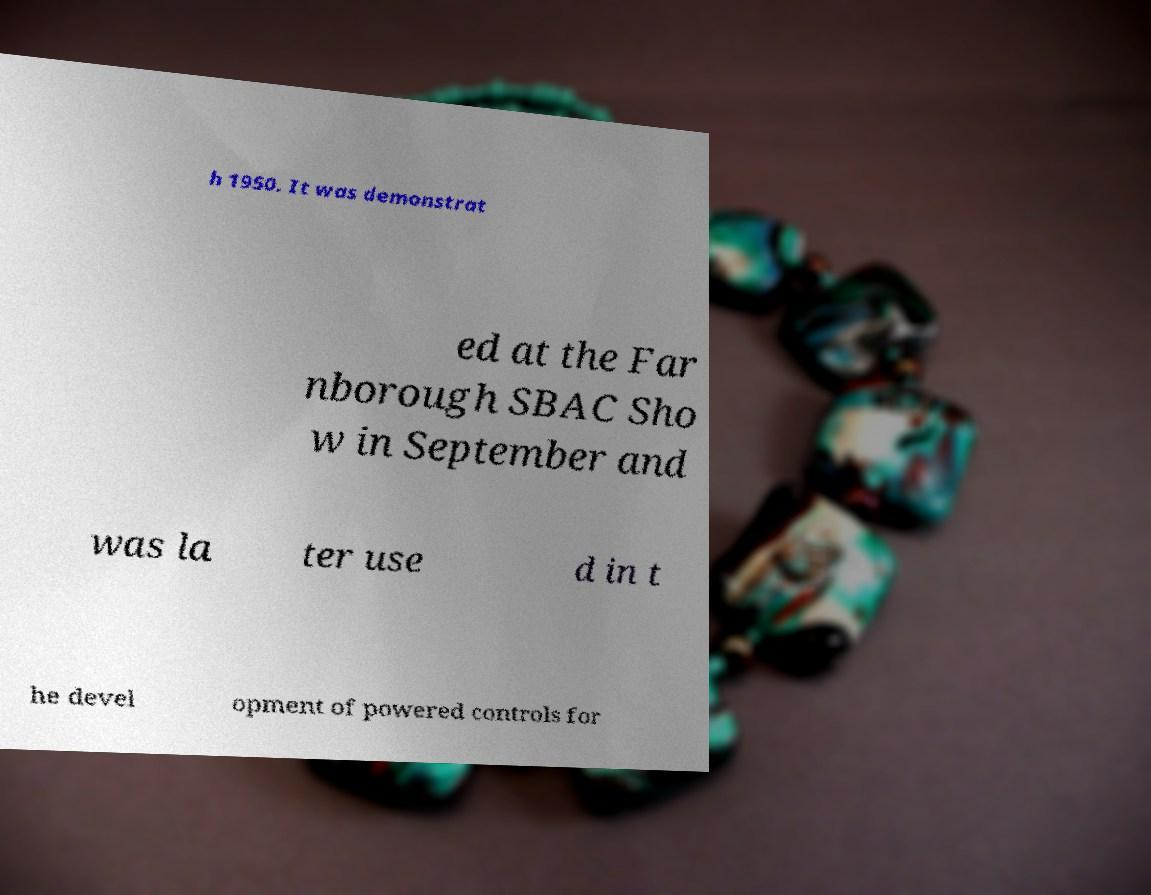I need the written content from this picture converted into text. Can you do that? h 1950. It was demonstrat ed at the Far nborough SBAC Sho w in September and was la ter use d in t he devel opment of powered controls for 